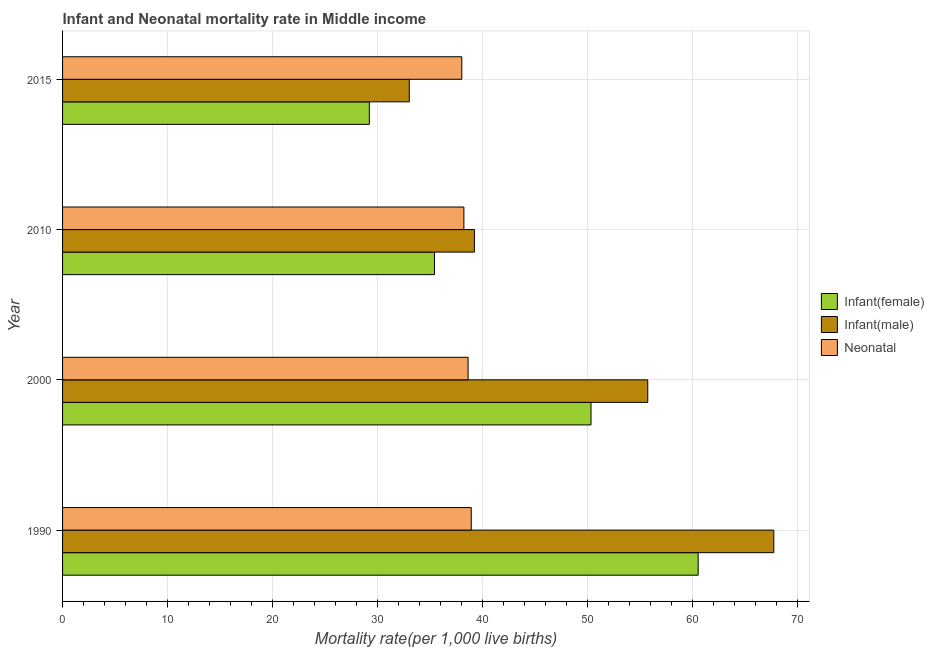How many different coloured bars are there?
Keep it short and to the point. 3. Are the number of bars per tick equal to the number of legend labels?
Offer a terse response. Yes. How many bars are there on the 1st tick from the top?
Give a very brief answer. 3. How many bars are there on the 3rd tick from the bottom?
Your answer should be compact. 3. In how many cases, is the number of bars for a given year not equal to the number of legend labels?
Offer a terse response. 0. What is the infant mortality rate(female) in 2015?
Offer a terse response. 29.2. Across all years, what is the maximum infant mortality rate(female)?
Provide a succinct answer. 60.5. Across all years, what is the minimum neonatal mortality rate?
Keep it short and to the point. 38. In which year was the infant mortality rate(female) maximum?
Your response must be concise. 1990. In which year was the infant mortality rate(female) minimum?
Give a very brief answer. 2015. What is the total infant mortality rate(female) in the graph?
Provide a succinct answer. 175.4. What is the difference between the neonatal mortality rate in 2000 and that in 2015?
Offer a very short reply. 0.6. What is the difference between the infant mortality rate(female) in 2000 and the infant mortality rate(male) in 2015?
Your answer should be very brief. 17.3. What is the average neonatal mortality rate per year?
Make the answer very short. 38.42. In the year 2010, what is the difference between the infant mortality rate(female) and neonatal mortality rate?
Offer a very short reply. -2.8. In how many years, is the infant mortality rate(male) greater than 8 ?
Give a very brief answer. 4. What is the ratio of the infant mortality rate(female) in 1990 to that in 2010?
Ensure brevity in your answer.  1.71. What is the difference between the highest and the second highest neonatal mortality rate?
Ensure brevity in your answer.  0.3. What is the difference between the highest and the lowest infant mortality rate(female)?
Ensure brevity in your answer.  31.3. What does the 1st bar from the top in 2010 represents?
Ensure brevity in your answer.  Neonatal . What does the 3rd bar from the bottom in 1990 represents?
Provide a succinct answer. Neonatal . Are all the bars in the graph horizontal?
Your response must be concise. Yes. How many years are there in the graph?
Give a very brief answer. 4. What is the difference between two consecutive major ticks on the X-axis?
Provide a short and direct response. 10. Are the values on the major ticks of X-axis written in scientific E-notation?
Keep it short and to the point. No. Does the graph contain any zero values?
Ensure brevity in your answer.  No. Does the graph contain grids?
Provide a succinct answer. Yes. How are the legend labels stacked?
Offer a terse response. Vertical. What is the title of the graph?
Your answer should be very brief. Infant and Neonatal mortality rate in Middle income. Does "Financial account" appear as one of the legend labels in the graph?
Offer a terse response. No. What is the label or title of the X-axis?
Provide a short and direct response. Mortality rate(per 1,0 live births). What is the Mortality rate(per 1,000 live births) of Infant(female) in 1990?
Provide a succinct answer. 60.5. What is the Mortality rate(per 1,000 live births) of Infant(male) in 1990?
Keep it short and to the point. 67.7. What is the Mortality rate(per 1,000 live births) in Neonatal  in 1990?
Ensure brevity in your answer.  38.9. What is the Mortality rate(per 1,000 live births) of Infant(female) in 2000?
Your response must be concise. 50.3. What is the Mortality rate(per 1,000 live births) in Infant(male) in 2000?
Your answer should be compact. 55.7. What is the Mortality rate(per 1,000 live births) of Neonatal  in 2000?
Provide a succinct answer. 38.6. What is the Mortality rate(per 1,000 live births) of Infant(female) in 2010?
Offer a very short reply. 35.4. What is the Mortality rate(per 1,000 live births) in Infant(male) in 2010?
Provide a short and direct response. 39.2. What is the Mortality rate(per 1,000 live births) in Neonatal  in 2010?
Your answer should be compact. 38.2. What is the Mortality rate(per 1,000 live births) of Infant(female) in 2015?
Your response must be concise. 29.2. Across all years, what is the maximum Mortality rate(per 1,000 live births) in Infant(female)?
Keep it short and to the point. 60.5. Across all years, what is the maximum Mortality rate(per 1,000 live births) of Infant(male)?
Offer a very short reply. 67.7. Across all years, what is the maximum Mortality rate(per 1,000 live births) in Neonatal ?
Your response must be concise. 38.9. Across all years, what is the minimum Mortality rate(per 1,000 live births) of Infant(female)?
Provide a short and direct response. 29.2. Across all years, what is the minimum Mortality rate(per 1,000 live births) in Infant(male)?
Make the answer very short. 33. Across all years, what is the minimum Mortality rate(per 1,000 live births) of Neonatal ?
Ensure brevity in your answer.  38. What is the total Mortality rate(per 1,000 live births) of Infant(female) in the graph?
Offer a very short reply. 175.4. What is the total Mortality rate(per 1,000 live births) of Infant(male) in the graph?
Offer a very short reply. 195.6. What is the total Mortality rate(per 1,000 live births) of Neonatal  in the graph?
Ensure brevity in your answer.  153.7. What is the difference between the Mortality rate(per 1,000 live births) in Infant(female) in 1990 and that in 2000?
Offer a very short reply. 10.2. What is the difference between the Mortality rate(per 1,000 live births) of Infant(male) in 1990 and that in 2000?
Your answer should be compact. 12. What is the difference between the Mortality rate(per 1,000 live births) in Infant(female) in 1990 and that in 2010?
Your response must be concise. 25.1. What is the difference between the Mortality rate(per 1,000 live births) in Infant(male) in 1990 and that in 2010?
Keep it short and to the point. 28.5. What is the difference between the Mortality rate(per 1,000 live births) in Neonatal  in 1990 and that in 2010?
Make the answer very short. 0.7. What is the difference between the Mortality rate(per 1,000 live births) of Infant(female) in 1990 and that in 2015?
Provide a short and direct response. 31.3. What is the difference between the Mortality rate(per 1,000 live births) of Infant(male) in 1990 and that in 2015?
Your answer should be very brief. 34.7. What is the difference between the Mortality rate(per 1,000 live births) in Neonatal  in 1990 and that in 2015?
Keep it short and to the point. 0.9. What is the difference between the Mortality rate(per 1,000 live births) of Infant(male) in 2000 and that in 2010?
Give a very brief answer. 16.5. What is the difference between the Mortality rate(per 1,000 live births) in Neonatal  in 2000 and that in 2010?
Ensure brevity in your answer.  0.4. What is the difference between the Mortality rate(per 1,000 live births) in Infant(female) in 2000 and that in 2015?
Your answer should be very brief. 21.1. What is the difference between the Mortality rate(per 1,000 live births) of Infant(male) in 2000 and that in 2015?
Your response must be concise. 22.7. What is the difference between the Mortality rate(per 1,000 live births) of Neonatal  in 2010 and that in 2015?
Ensure brevity in your answer.  0.2. What is the difference between the Mortality rate(per 1,000 live births) of Infant(female) in 1990 and the Mortality rate(per 1,000 live births) of Infant(male) in 2000?
Offer a terse response. 4.8. What is the difference between the Mortality rate(per 1,000 live births) in Infant(female) in 1990 and the Mortality rate(per 1,000 live births) in Neonatal  in 2000?
Make the answer very short. 21.9. What is the difference between the Mortality rate(per 1,000 live births) of Infant(male) in 1990 and the Mortality rate(per 1,000 live births) of Neonatal  in 2000?
Your answer should be compact. 29.1. What is the difference between the Mortality rate(per 1,000 live births) in Infant(female) in 1990 and the Mortality rate(per 1,000 live births) in Infant(male) in 2010?
Offer a very short reply. 21.3. What is the difference between the Mortality rate(per 1,000 live births) in Infant(female) in 1990 and the Mortality rate(per 1,000 live births) in Neonatal  in 2010?
Make the answer very short. 22.3. What is the difference between the Mortality rate(per 1,000 live births) in Infant(male) in 1990 and the Mortality rate(per 1,000 live births) in Neonatal  in 2010?
Give a very brief answer. 29.5. What is the difference between the Mortality rate(per 1,000 live births) in Infant(female) in 1990 and the Mortality rate(per 1,000 live births) in Infant(male) in 2015?
Your response must be concise. 27.5. What is the difference between the Mortality rate(per 1,000 live births) of Infant(male) in 1990 and the Mortality rate(per 1,000 live births) of Neonatal  in 2015?
Give a very brief answer. 29.7. What is the difference between the Mortality rate(per 1,000 live births) in Infant(female) in 2000 and the Mortality rate(per 1,000 live births) in Neonatal  in 2010?
Offer a very short reply. 12.1. What is the difference between the Mortality rate(per 1,000 live births) of Infant(male) in 2000 and the Mortality rate(per 1,000 live births) of Neonatal  in 2010?
Provide a succinct answer. 17.5. What is the difference between the Mortality rate(per 1,000 live births) of Infant(female) in 2000 and the Mortality rate(per 1,000 live births) of Neonatal  in 2015?
Offer a terse response. 12.3. What is the difference between the Mortality rate(per 1,000 live births) of Infant(female) in 2010 and the Mortality rate(per 1,000 live births) of Infant(male) in 2015?
Give a very brief answer. 2.4. What is the difference between the Mortality rate(per 1,000 live births) of Infant(female) in 2010 and the Mortality rate(per 1,000 live births) of Neonatal  in 2015?
Your answer should be compact. -2.6. What is the difference between the Mortality rate(per 1,000 live births) in Infant(male) in 2010 and the Mortality rate(per 1,000 live births) in Neonatal  in 2015?
Provide a short and direct response. 1.2. What is the average Mortality rate(per 1,000 live births) of Infant(female) per year?
Provide a succinct answer. 43.85. What is the average Mortality rate(per 1,000 live births) of Infant(male) per year?
Your response must be concise. 48.9. What is the average Mortality rate(per 1,000 live births) in Neonatal  per year?
Ensure brevity in your answer.  38.42. In the year 1990, what is the difference between the Mortality rate(per 1,000 live births) in Infant(female) and Mortality rate(per 1,000 live births) in Neonatal ?
Your response must be concise. 21.6. In the year 1990, what is the difference between the Mortality rate(per 1,000 live births) in Infant(male) and Mortality rate(per 1,000 live births) in Neonatal ?
Make the answer very short. 28.8. In the year 2000, what is the difference between the Mortality rate(per 1,000 live births) of Infant(female) and Mortality rate(per 1,000 live births) of Neonatal ?
Provide a short and direct response. 11.7. In the year 2010, what is the difference between the Mortality rate(per 1,000 live births) in Infant(female) and Mortality rate(per 1,000 live births) in Infant(male)?
Offer a terse response. -3.8. In the year 2010, what is the difference between the Mortality rate(per 1,000 live births) in Infant(female) and Mortality rate(per 1,000 live births) in Neonatal ?
Offer a very short reply. -2.8. In the year 2010, what is the difference between the Mortality rate(per 1,000 live births) in Infant(male) and Mortality rate(per 1,000 live births) in Neonatal ?
Your answer should be very brief. 1. What is the ratio of the Mortality rate(per 1,000 live births) in Infant(female) in 1990 to that in 2000?
Ensure brevity in your answer.  1.2. What is the ratio of the Mortality rate(per 1,000 live births) of Infant(male) in 1990 to that in 2000?
Keep it short and to the point. 1.22. What is the ratio of the Mortality rate(per 1,000 live births) of Neonatal  in 1990 to that in 2000?
Your answer should be compact. 1.01. What is the ratio of the Mortality rate(per 1,000 live births) of Infant(female) in 1990 to that in 2010?
Offer a terse response. 1.71. What is the ratio of the Mortality rate(per 1,000 live births) of Infant(male) in 1990 to that in 2010?
Your response must be concise. 1.73. What is the ratio of the Mortality rate(per 1,000 live births) in Neonatal  in 1990 to that in 2010?
Offer a very short reply. 1.02. What is the ratio of the Mortality rate(per 1,000 live births) of Infant(female) in 1990 to that in 2015?
Provide a succinct answer. 2.07. What is the ratio of the Mortality rate(per 1,000 live births) of Infant(male) in 1990 to that in 2015?
Provide a short and direct response. 2.05. What is the ratio of the Mortality rate(per 1,000 live births) in Neonatal  in 1990 to that in 2015?
Your answer should be compact. 1.02. What is the ratio of the Mortality rate(per 1,000 live births) in Infant(female) in 2000 to that in 2010?
Offer a terse response. 1.42. What is the ratio of the Mortality rate(per 1,000 live births) in Infant(male) in 2000 to that in 2010?
Keep it short and to the point. 1.42. What is the ratio of the Mortality rate(per 1,000 live births) of Neonatal  in 2000 to that in 2010?
Give a very brief answer. 1.01. What is the ratio of the Mortality rate(per 1,000 live births) of Infant(female) in 2000 to that in 2015?
Keep it short and to the point. 1.72. What is the ratio of the Mortality rate(per 1,000 live births) of Infant(male) in 2000 to that in 2015?
Provide a succinct answer. 1.69. What is the ratio of the Mortality rate(per 1,000 live births) in Neonatal  in 2000 to that in 2015?
Keep it short and to the point. 1.02. What is the ratio of the Mortality rate(per 1,000 live births) in Infant(female) in 2010 to that in 2015?
Offer a terse response. 1.21. What is the ratio of the Mortality rate(per 1,000 live births) of Infant(male) in 2010 to that in 2015?
Offer a very short reply. 1.19. What is the difference between the highest and the second highest Mortality rate(per 1,000 live births) of Neonatal ?
Offer a terse response. 0.3. What is the difference between the highest and the lowest Mortality rate(per 1,000 live births) in Infant(female)?
Make the answer very short. 31.3. What is the difference between the highest and the lowest Mortality rate(per 1,000 live births) in Infant(male)?
Keep it short and to the point. 34.7. 